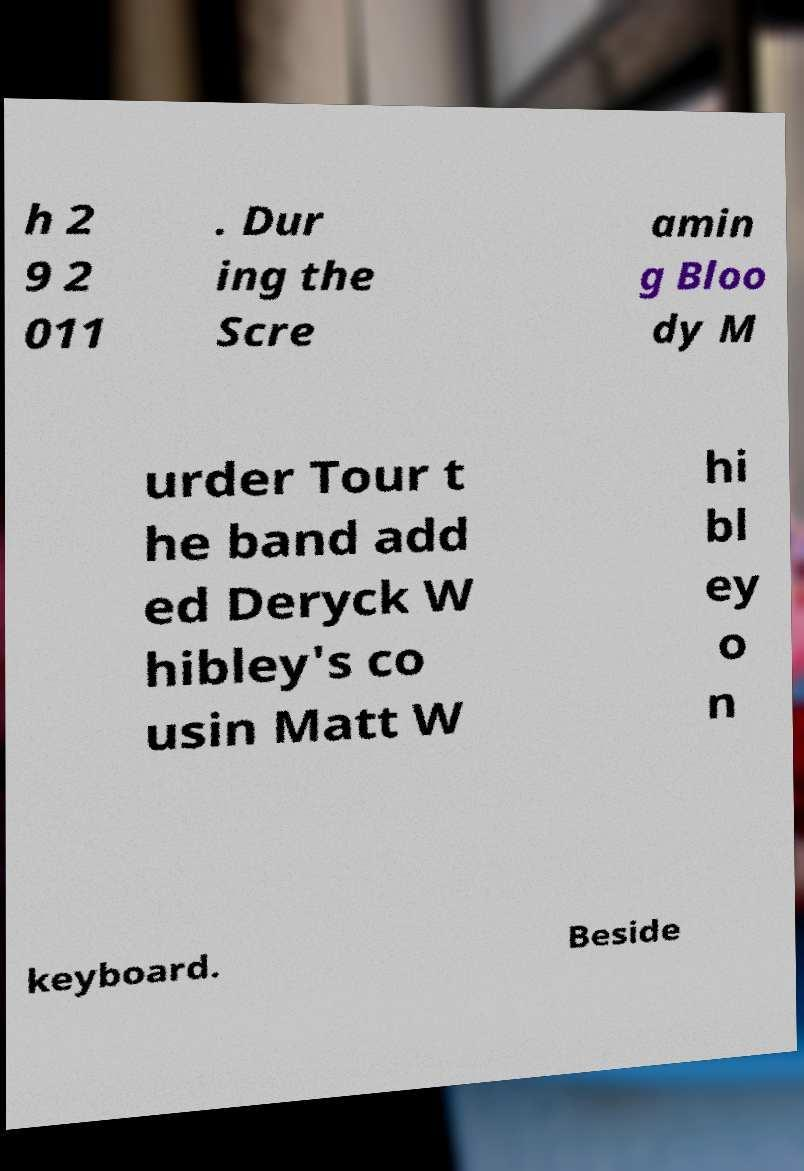I need the written content from this picture converted into text. Can you do that? h 2 9 2 011 . Dur ing the Scre amin g Bloo dy M urder Tour t he band add ed Deryck W hibley's co usin Matt W hi bl ey o n keyboard. Beside 